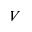Convert formula to latex. <formula><loc_0><loc_0><loc_500><loc_500>V</formula> 